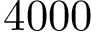<formula> <loc_0><loc_0><loc_500><loc_500>4 0 0 0</formula> 